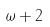<formula> <loc_0><loc_0><loc_500><loc_500>\omega + 2</formula> 